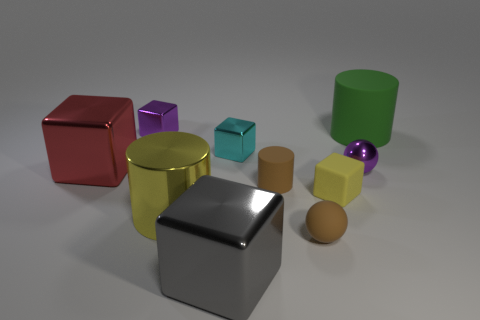Subtract 1 blocks. How many blocks are left? 4 Subtract all purple metal cubes. How many cubes are left? 4 Subtract all blue blocks. Subtract all purple balls. How many blocks are left? 5 Subtract all cylinders. How many objects are left? 7 Subtract all cylinders. Subtract all purple shiny cubes. How many objects are left? 6 Add 6 small matte cubes. How many small matte cubes are left? 7 Add 7 cylinders. How many cylinders exist? 10 Subtract 1 cyan blocks. How many objects are left? 9 